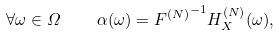Convert formula to latex. <formula><loc_0><loc_0><loc_500><loc_500>\forall \omega \in \varOmega \quad \alpha ( \omega ) = { F ^ { ( N ) } } ^ { - 1 } H _ { X } ^ { ( N ) } ( \omega ) ,</formula> 